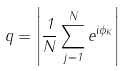<formula> <loc_0><loc_0><loc_500><loc_500>q = \left | \frac { 1 } { N } \sum _ { j = 1 } ^ { N } e ^ { i \phi _ { K } } \right |</formula> 